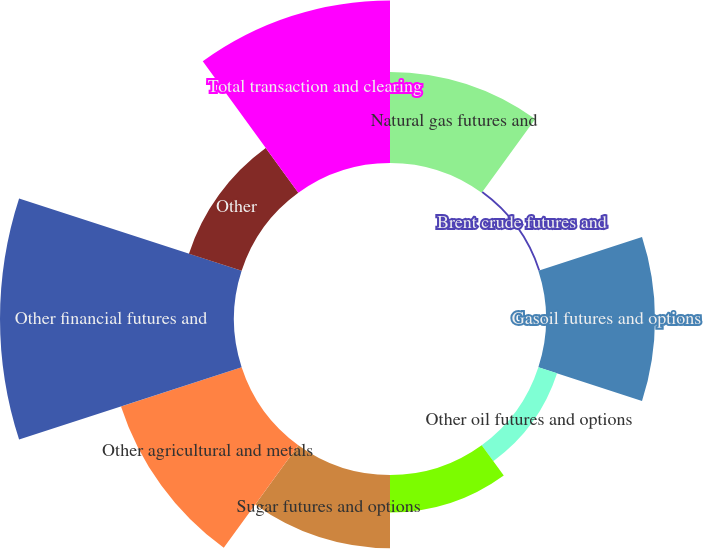Convert chart to OTSL. <chart><loc_0><loc_0><loc_500><loc_500><pie_chart><fcel>Natural gas futures and<fcel>Brent crude futures and<fcel>Gasoil futures and options<fcel>Other oil futures and options<fcel>Power futures and options<fcel>Sugar futures and options<fcel>Other agricultural and metals<fcel>Other financial futures and<fcel>Other<fcel>Total transaction and clearing<nl><fcel>10.0%<fcel>0.2%<fcel>11.96%<fcel>2.16%<fcel>4.12%<fcel>8.04%<fcel>13.92%<fcel>25.68%<fcel>6.08%<fcel>17.84%<nl></chart> 